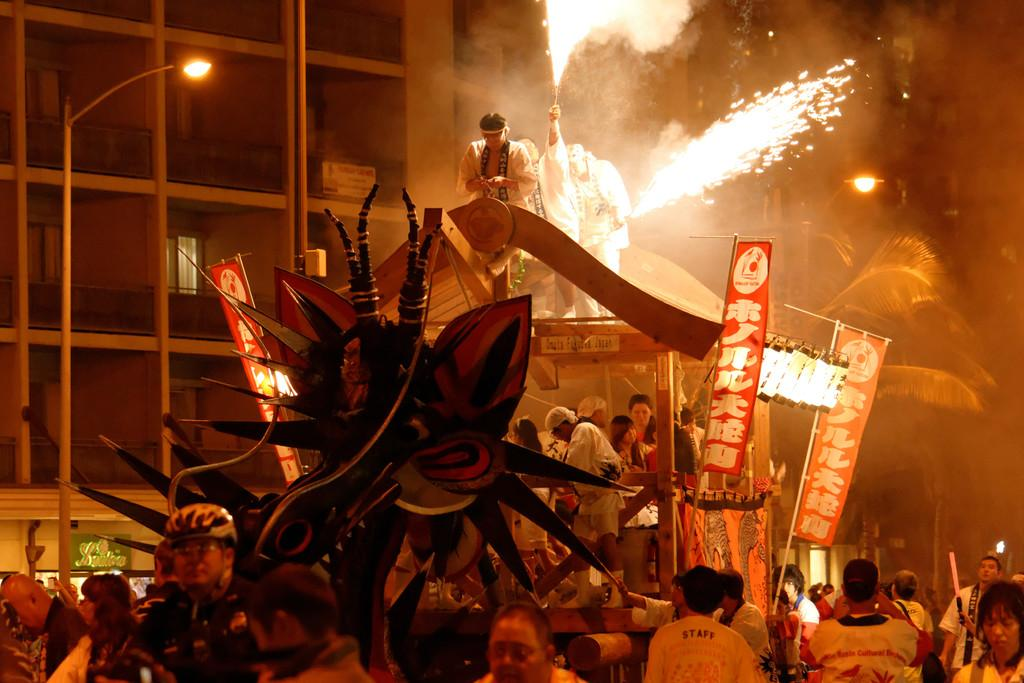What is the main subject in the center of the image? There are people in the center of the image. What is the source of light visible in the image? There is a street light in the image. What can be seen in the background of the image? There is a building in the background of the image. What type of decorations are present in the image? There are banners in the image. What type of account does the street light have in the image? There is no mention of an account associated with the street light in the image. 